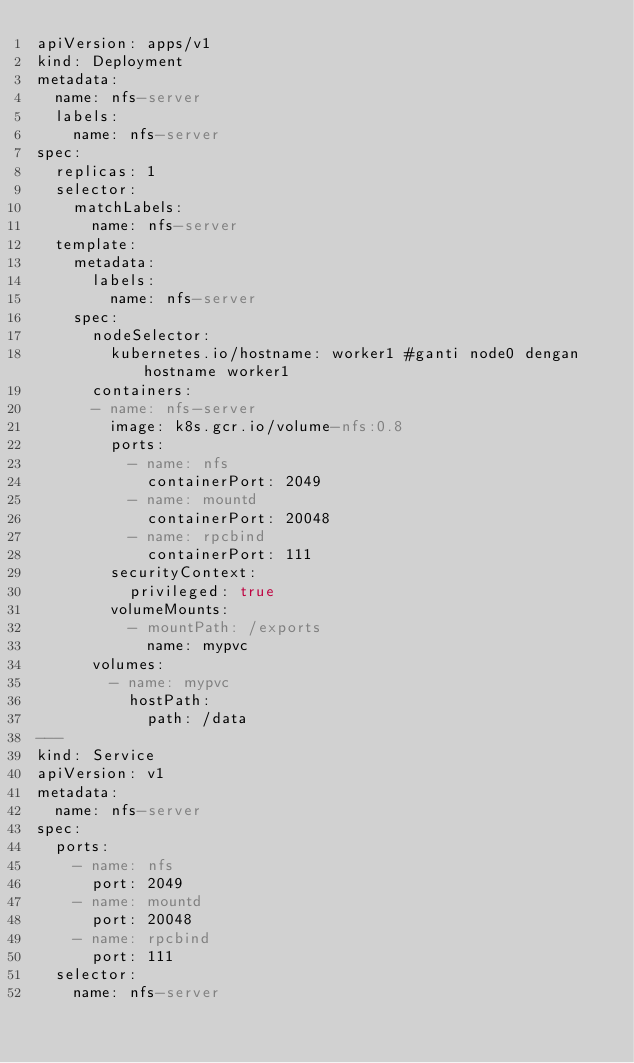Convert code to text. <code><loc_0><loc_0><loc_500><loc_500><_YAML_>apiVersion: apps/v1
kind: Deployment
metadata:
  name: nfs-server
  labels:
    name: nfs-server
spec:
  replicas: 1
  selector:
    matchLabels:
      name: nfs-server
  template:
    metadata:
      labels:
        name: nfs-server
    spec:
      nodeSelector: 
        kubernetes.io/hostname: worker1 #ganti node0 dengan hostname worker1
      containers:
      - name: nfs-server
        image: k8s.gcr.io/volume-nfs:0.8
        ports:
          - name: nfs
            containerPort: 2049
          - name: mountd
            containerPort: 20048
          - name: rpcbind
            containerPort: 111
        securityContext:
          privileged: true
        volumeMounts:
          - mountPath: /exports
            name: mypvc
      volumes:
        - name: mypvc
          hostPath:
            path: /data
---
kind: Service
apiVersion: v1
metadata:
  name: nfs-server
spec:
  ports:
    - name: nfs
      port: 2049
    - name: mountd
      port: 20048
    - name: rpcbind
      port: 111
  selector:
    name: nfs-server</code> 